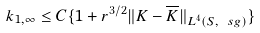Convert formula to latex. <formula><loc_0><loc_0><loc_500><loc_500>k _ { 1 , \infty } \leq C \{ 1 + r ^ { 3 / 2 } \| K - \overline { K } \| _ { L ^ { 4 } ( S , \ s g ) } \}</formula> 